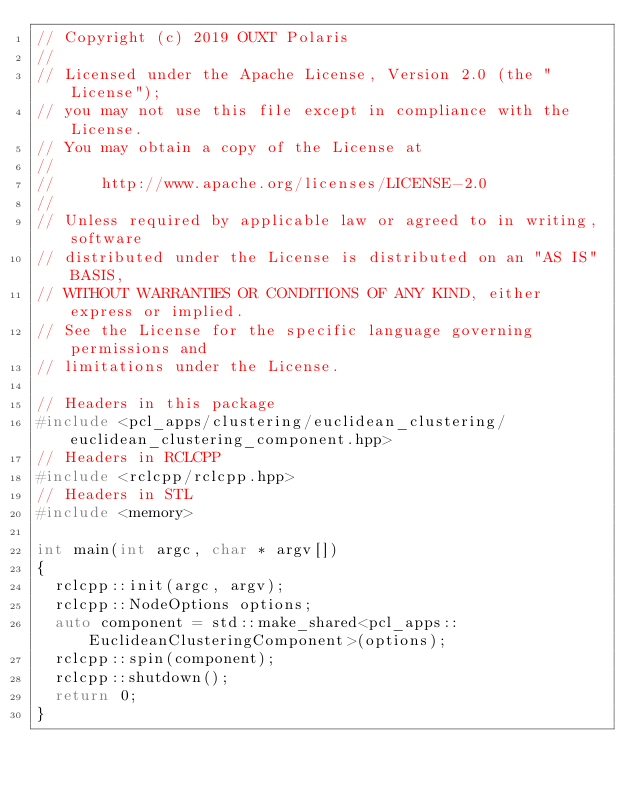<code> <loc_0><loc_0><loc_500><loc_500><_C++_>// Copyright (c) 2019 OUXT Polaris
//
// Licensed under the Apache License, Version 2.0 (the "License");
// you may not use this file except in compliance with the License.
// You may obtain a copy of the License at
//
//     http://www.apache.org/licenses/LICENSE-2.0
//
// Unless required by applicable law or agreed to in writing, software
// distributed under the License is distributed on an "AS IS" BASIS,
// WITHOUT WARRANTIES OR CONDITIONS OF ANY KIND, either express or implied.
// See the License for the specific language governing permissions and
// limitations under the License.

// Headers in this package
#include <pcl_apps/clustering/euclidean_clustering/euclidean_clustering_component.hpp>
// Headers in RCLCPP
#include <rclcpp/rclcpp.hpp>
// Headers in STL
#include <memory>

int main(int argc, char * argv[])
{
  rclcpp::init(argc, argv);
  rclcpp::NodeOptions options;
  auto component = std::make_shared<pcl_apps::EuclideanClusteringComponent>(options);
  rclcpp::spin(component);
  rclcpp::shutdown();
  return 0;
}
</code> 